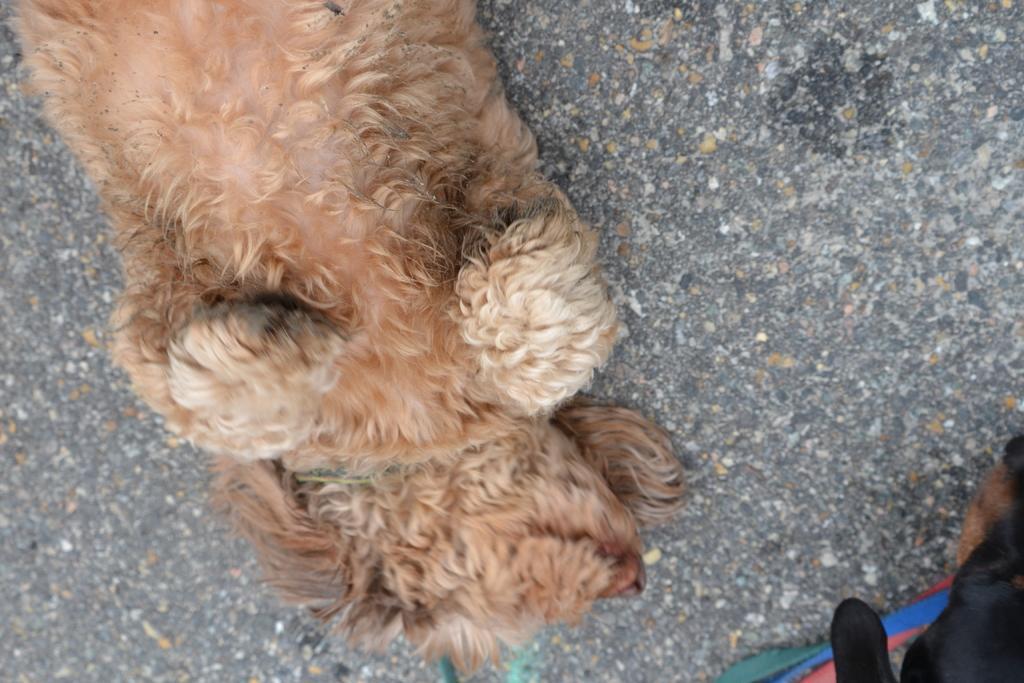In one or two sentences, can you explain what this image depicts? In this image we can see a dog which is brown in color is resting on ground and in the bottom right of the image we can see another dog. 